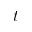<formula> <loc_0><loc_0><loc_500><loc_500>t</formula> 